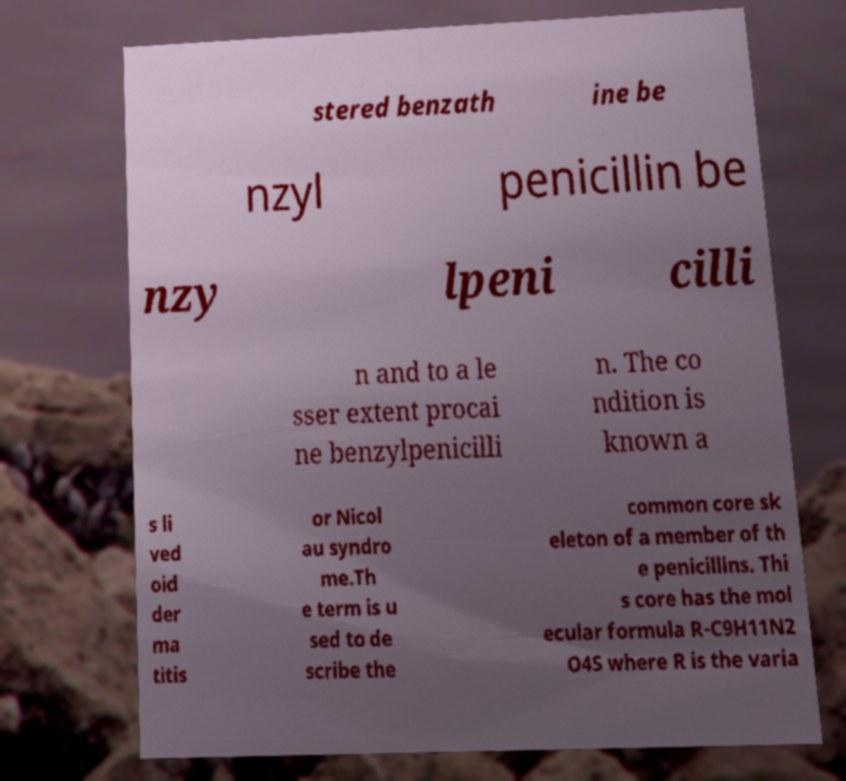Could you assist in decoding the text presented in this image and type it out clearly? stered benzath ine be nzyl penicillin be nzy lpeni cilli n and to a le sser extent procai ne benzylpenicilli n. The co ndition is known a s li ved oid der ma titis or Nicol au syndro me.Th e term is u sed to de scribe the common core sk eleton of a member of th e penicillins. Thi s core has the mol ecular formula R-C9H11N2 O4S where R is the varia 